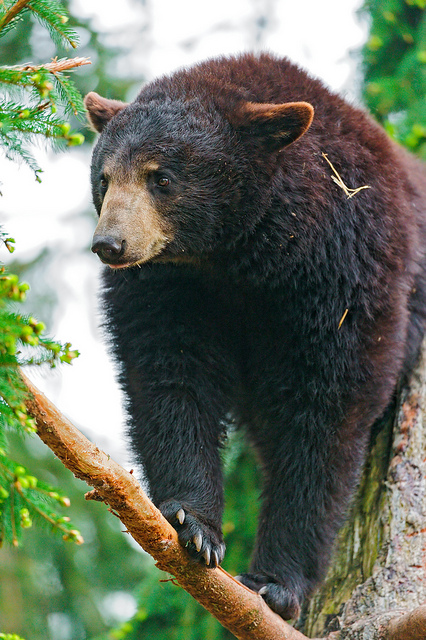What might this bear be thinking as it perches on the branch? The bear might be contemplating its next move, deciding whether to climb higher, descend, or stay put. It could be scanning the area for potential food sources or keeping an eye out for any signs of danger. Alternatively, it might just be enjoying the view from its elevated position, feeling safe and curious about its surrounding environment. Can you describe a day in the life of this young bear in its natural habitat? A typical day for this young bear starts with waking up from its den. After a good stretch, it might set out to forage for food, sniffing the air for the scent of berries, nuts, or other edibles. Throughout the day, the bear explores its surroundings, climbing trees, wading through streams, and turning over rocks to find insects or small animals. If it encounters other bears, especially larger ones, it might quickly climb a tree for safety. Play and exploration take up a significant part of its day, as these activities help it learn about its environment and develop essential survival skills. By dusk, the bear returns to a safe place to rest, perhaps a sheltered spot in the woods, where it settles down and falls asleep under the stars, ready to start a new day of adventure tomorrow. Imagine if this bear could talk for a day. What would it say about its life and experiences? If this bear could talk for a day, it might say, 'Life in the forest is full of surprises. Every day, I wake up to the sound of birds singing and the rustling of leaves. I spend my time searching for food - berries, nuts, and sometimes honey, if I'm lucky! Climbing trees is my favorite; from up high, I can see so much, and it's also my safe haven when bigger bears are around. I've met many creatures in this forest, some friendly, some not so much. Every encounter teaches me something new. The best part is the freedom to roam and explore. The woods are like an endless playground, full of mysteries waiting to be discovered. It's a challenging life at times, but I wouldn't trade it for anything.' If you were to write a children's story about this bear's adventure, how would it start? Once upon a time, deep in a lush, vibrant forest, there lived a curious young bear named Bruno. Bruno loved to climb trees and explore every nook and cranny of his woodland home. One sunny morning, Bruno woke up with a twinkle in his eye. 'Today feels like a day for an adventure,' he thought, as he stretched his furry limbs. With his belly rumbling for some delicious berries, Bruno set off on his journey, humming a cheerful tune. Little did he know, today's adventure would lead him to unexpected wonders and new friends, turning an ordinary day into a tale he would remember forever. 